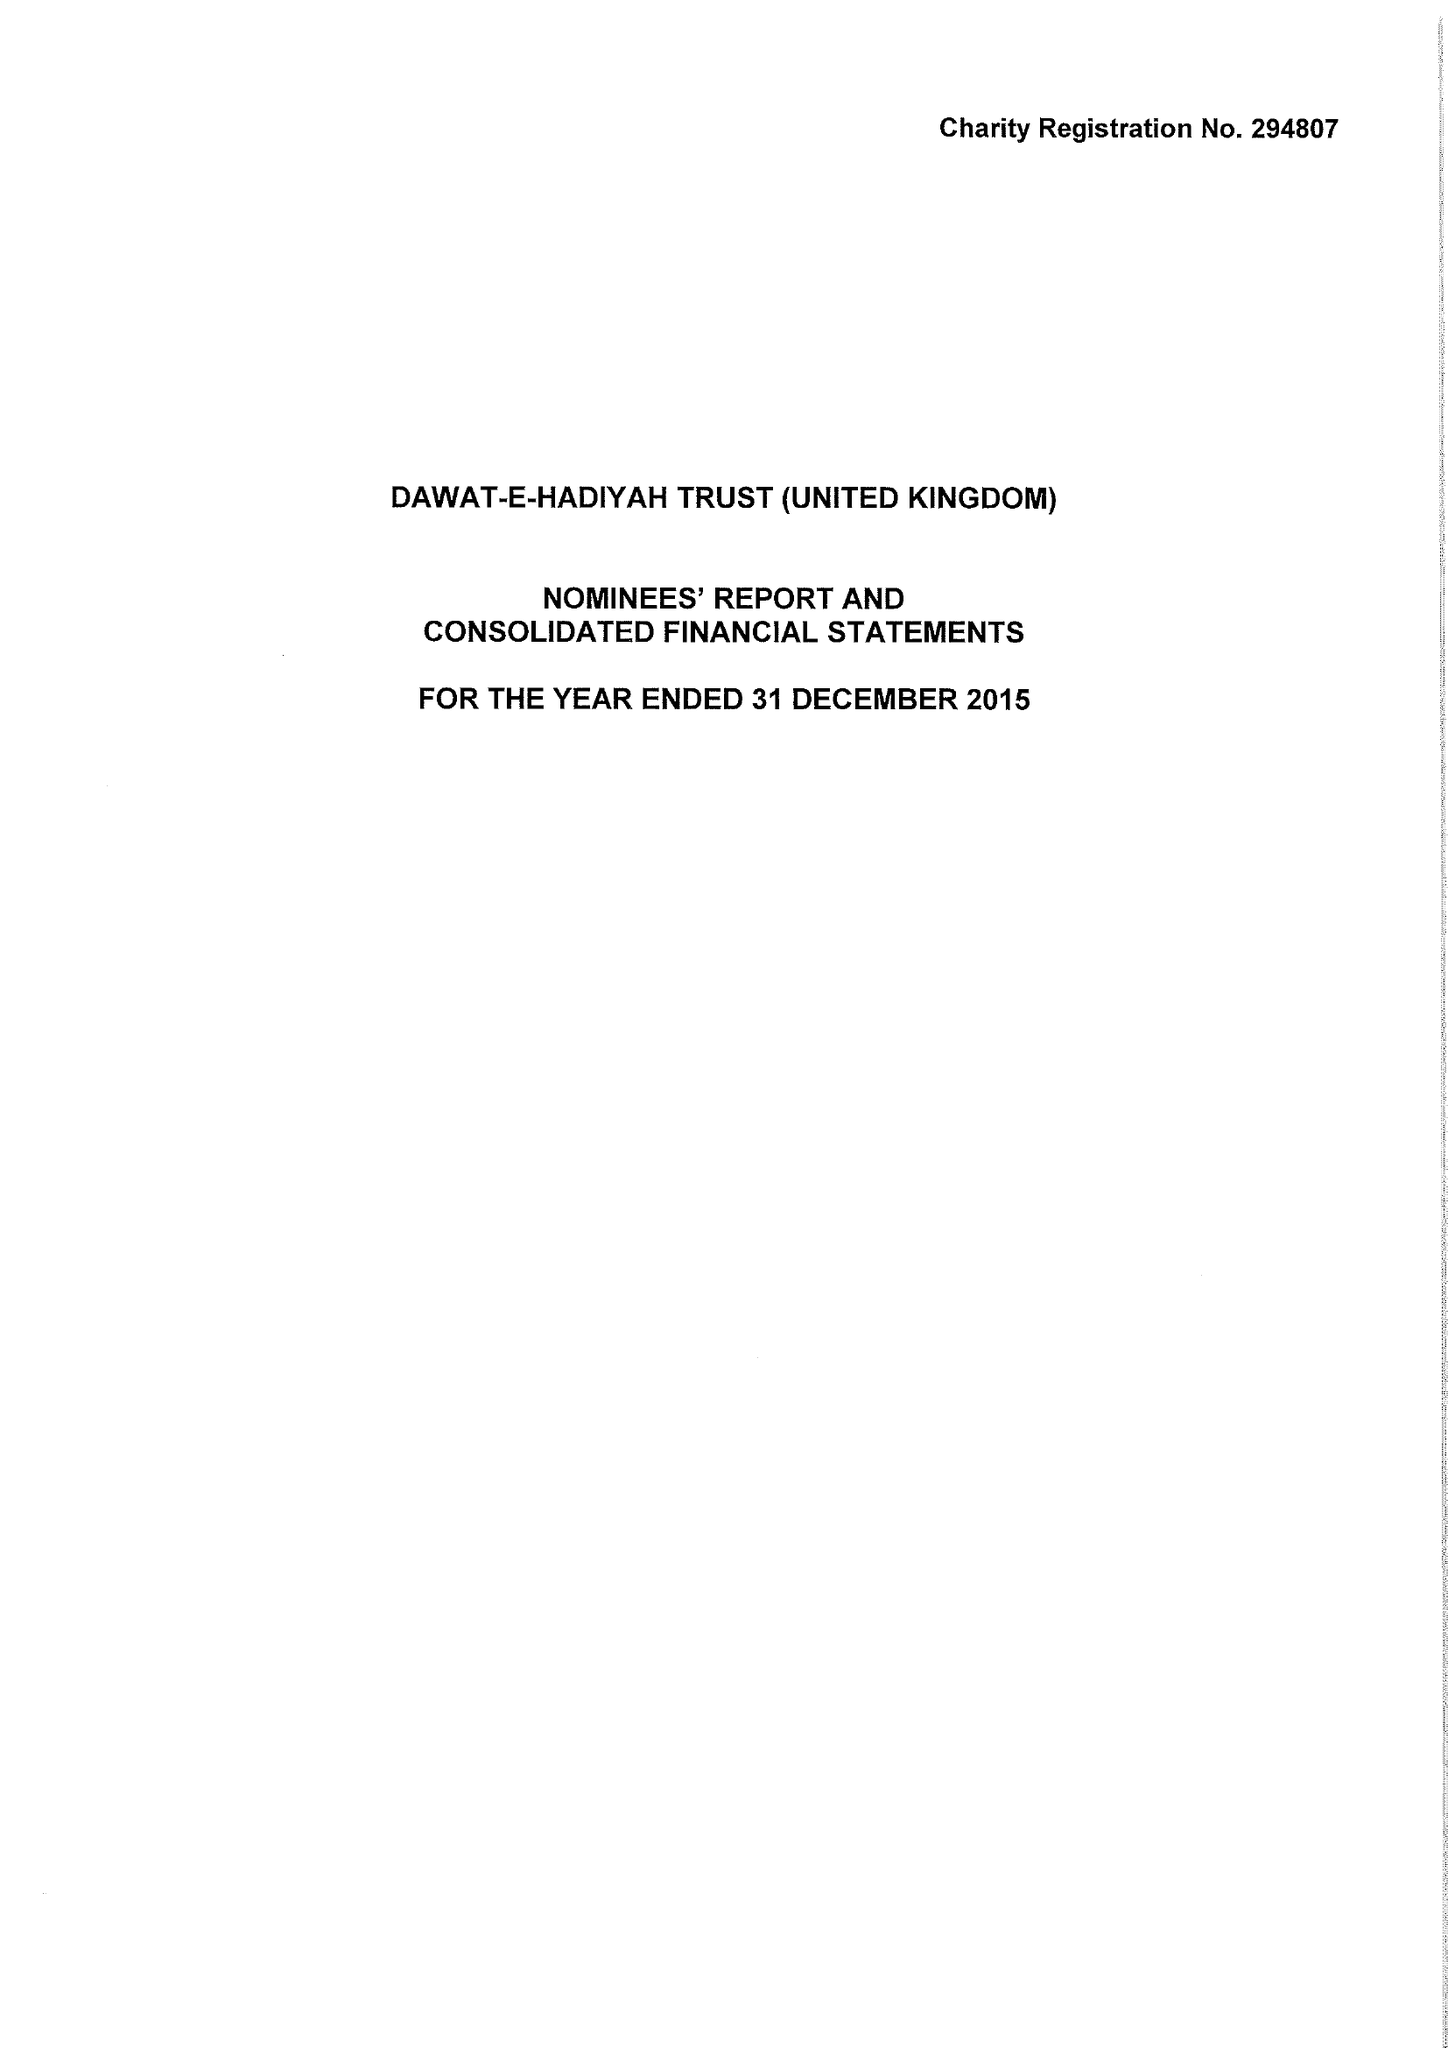What is the value for the report_date?
Answer the question using a single word or phrase. 2015-12-31 